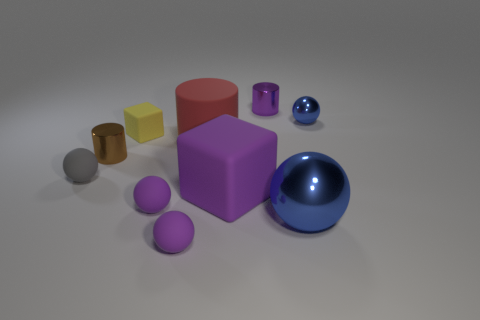How would you describe the overall composition of objects in this image? The image displays a collection of geometric shapes and objects arranged in a seemingly random composition. The objects vary in size, color, and material, featuring spheres, cylinders, and cubes. The colors range from muted to vivid, providing a contrast that makes the arrangement visually interesting. 